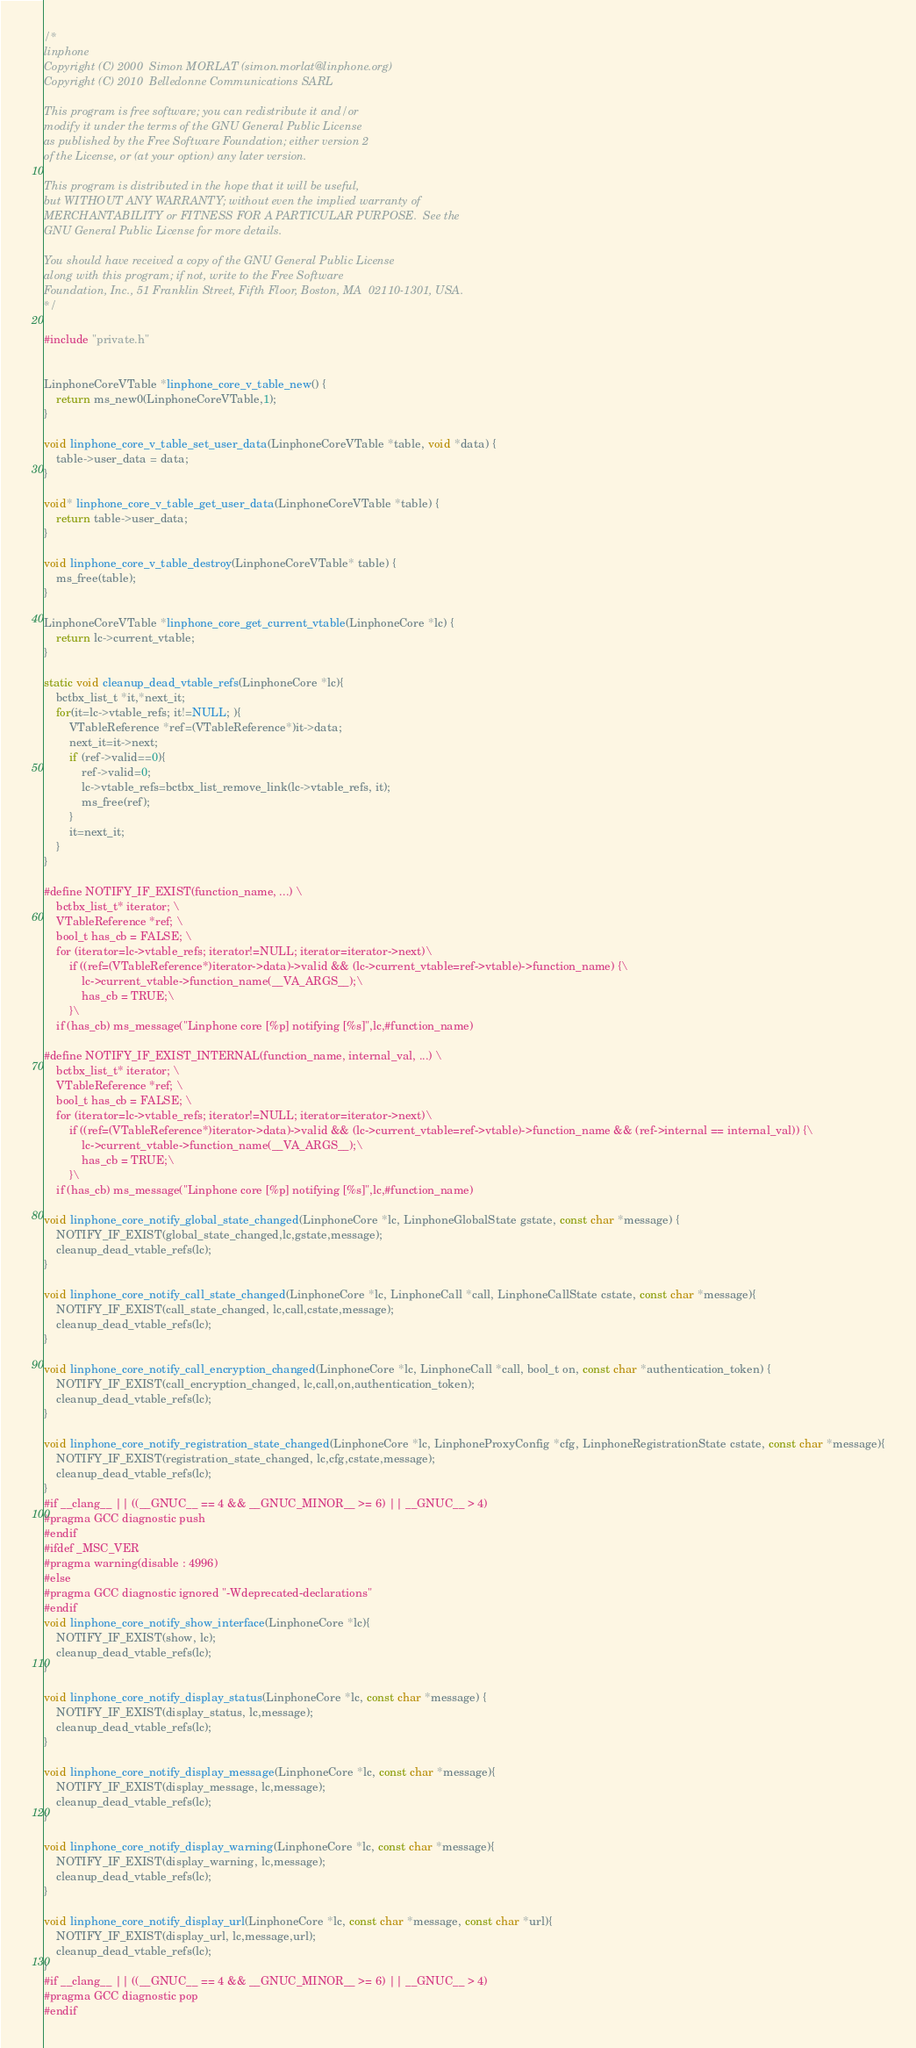Convert code to text. <code><loc_0><loc_0><loc_500><loc_500><_C_>/*
linphone
Copyright (C) 2000  Simon MORLAT (simon.morlat@linphone.org)
Copyright (C) 2010  Belledonne Communications SARL

This program is free software; you can redistribute it and/or
modify it under the terms of the GNU General Public License
as published by the Free Software Foundation; either version 2
of the License, or (at your option) any later version.

This program is distributed in the hope that it will be useful,
but WITHOUT ANY WARRANTY; without even the implied warranty of
MERCHANTABILITY or FITNESS FOR A PARTICULAR PURPOSE.  See the
GNU General Public License for more details.

You should have received a copy of the GNU General Public License
along with this program; if not, write to the Free Software
Foundation, Inc., 51 Franklin Street, Fifth Floor, Boston, MA  02110-1301, USA.
*/

#include "private.h"


LinphoneCoreVTable *linphone_core_v_table_new() {
	return ms_new0(LinphoneCoreVTable,1);
}

void linphone_core_v_table_set_user_data(LinphoneCoreVTable *table, void *data) {
	table->user_data = data;
}

void* linphone_core_v_table_get_user_data(LinphoneCoreVTable *table) {
	return table->user_data;
}

void linphone_core_v_table_destroy(LinphoneCoreVTable* table) {
	ms_free(table);
}

LinphoneCoreVTable *linphone_core_get_current_vtable(LinphoneCore *lc) {
	return lc->current_vtable;
}

static void cleanup_dead_vtable_refs(LinphoneCore *lc){
	bctbx_list_t *it,*next_it;
	for(it=lc->vtable_refs; it!=NULL; ){
		VTableReference *ref=(VTableReference*)it->data;
		next_it=it->next;
		if (ref->valid==0){
			ref->valid=0;
			lc->vtable_refs=bctbx_list_remove_link(lc->vtable_refs, it);
			ms_free(ref);
		}
		it=next_it;
	}
}

#define NOTIFY_IF_EXIST(function_name, ...) \
	bctbx_list_t* iterator; \
	VTableReference *ref; \
	bool_t has_cb = FALSE; \
	for (iterator=lc->vtable_refs; iterator!=NULL; iterator=iterator->next)\
		if ((ref=(VTableReference*)iterator->data)->valid && (lc->current_vtable=ref->vtable)->function_name) {\
			lc->current_vtable->function_name(__VA_ARGS__);\
			has_cb = TRUE;\
		}\
	if (has_cb) ms_message("Linphone core [%p] notifying [%s]",lc,#function_name)

#define NOTIFY_IF_EXIST_INTERNAL(function_name, internal_val, ...) \
	bctbx_list_t* iterator; \
	VTableReference *ref; \
	bool_t has_cb = FALSE; \
	for (iterator=lc->vtable_refs; iterator!=NULL; iterator=iterator->next)\
		if ((ref=(VTableReference*)iterator->data)->valid && (lc->current_vtable=ref->vtable)->function_name && (ref->internal == internal_val)) {\
			lc->current_vtable->function_name(__VA_ARGS__);\
			has_cb = TRUE;\
		}\
	if (has_cb) ms_message("Linphone core [%p] notifying [%s]",lc,#function_name)

void linphone_core_notify_global_state_changed(LinphoneCore *lc, LinphoneGlobalState gstate, const char *message) {
	NOTIFY_IF_EXIST(global_state_changed,lc,gstate,message);
	cleanup_dead_vtable_refs(lc);
}

void linphone_core_notify_call_state_changed(LinphoneCore *lc, LinphoneCall *call, LinphoneCallState cstate, const char *message){
	NOTIFY_IF_EXIST(call_state_changed, lc,call,cstate,message);
	cleanup_dead_vtable_refs(lc);
}

void linphone_core_notify_call_encryption_changed(LinphoneCore *lc, LinphoneCall *call, bool_t on, const char *authentication_token) {
	NOTIFY_IF_EXIST(call_encryption_changed, lc,call,on,authentication_token);
	cleanup_dead_vtable_refs(lc);
}

void linphone_core_notify_registration_state_changed(LinphoneCore *lc, LinphoneProxyConfig *cfg, LinphoneRegistrationState cstate, const char *message){
	NOTIFY_IF_EXIST(registration_state_changed, lc,cfg,cstate,message);
	cleanup_dead_vtable_refs(lc);
}
#if __clang__ || ((__GNUC__ == 4 && __GNUC_MINOR__ >= 6) || __GNUC__ > 4)
#pragma GCC diagnostic push
#endif
#ifdef _MSC_VER
#pragma warning(disable : 4996)
#else
#pragma GCC diagnostic ignored "-Wdeprecated-declarations"
#endif
void linphone_core_notify_show_interface(LinphoneCore *lc){
	NOTIFY_IF_EXIST(show, lc);
	cleanup_dead_vtable_refs(lc);
}

void linphone_core_notify_display_status(LinphoneCore *lc, const char *message) {
	NOTIFY_IF_EXIST(display_status, lc,message);
	cleanup_dead_vtable_refs(lc);
}

void linphone_core_notify_display_message(LinphoneCore *lc, const char *message){
	NOTIFY_IF_EXIST(display_message, lc,message);
	cleanup_dead_vtable_refs(lc);
}

void linphone_core_notify_display_warning(LinphoneCore *lc, const char *message){
	NOTIFY_IF_EXIST(display_warning, lc,message);
	cleanup_dead_vtable_refs(lc);
}

void linphone_core_notify_display_url(LinphoneCore *lc, const char *message, const char *url){
	NOTIFY_IF_EXIST(display_url, lc,message,url);
	cleanup_dead_vtable_refs(lc);
}
#if __clang__ || ((__GNUC__ == 4 && __GNUC_MINOR__ >= 6) || __GNUC__ > 4)
#pragma GCC diagnostic pop
#endif</code> 